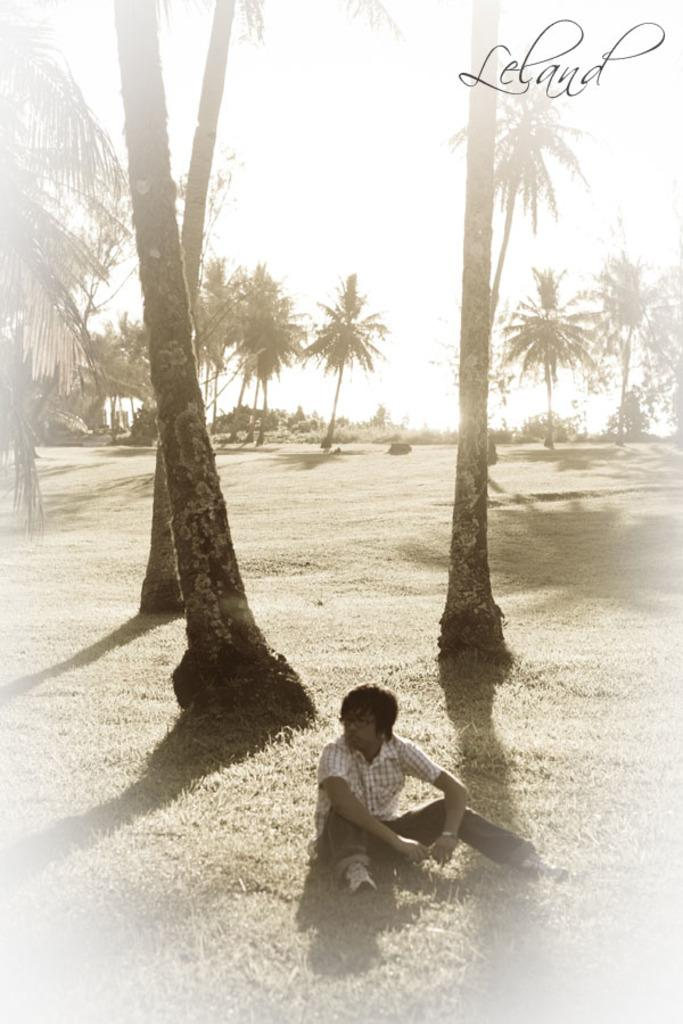What is the man in the image doing? The man is sitting on the grassy land. What can be seen in the background of the image? Trees and plants are visible behind the man. Is there any additional information about the image itself? Yes, there is a watermark in the right top of the image. What type of pest can be seen crawling on the man's shoulder in the image? There is no pest visible on the man's shoulder in the image. What kind of error is present in the image? There is no error present in the image; it appears to be a clear and accurate representation of the scene. 